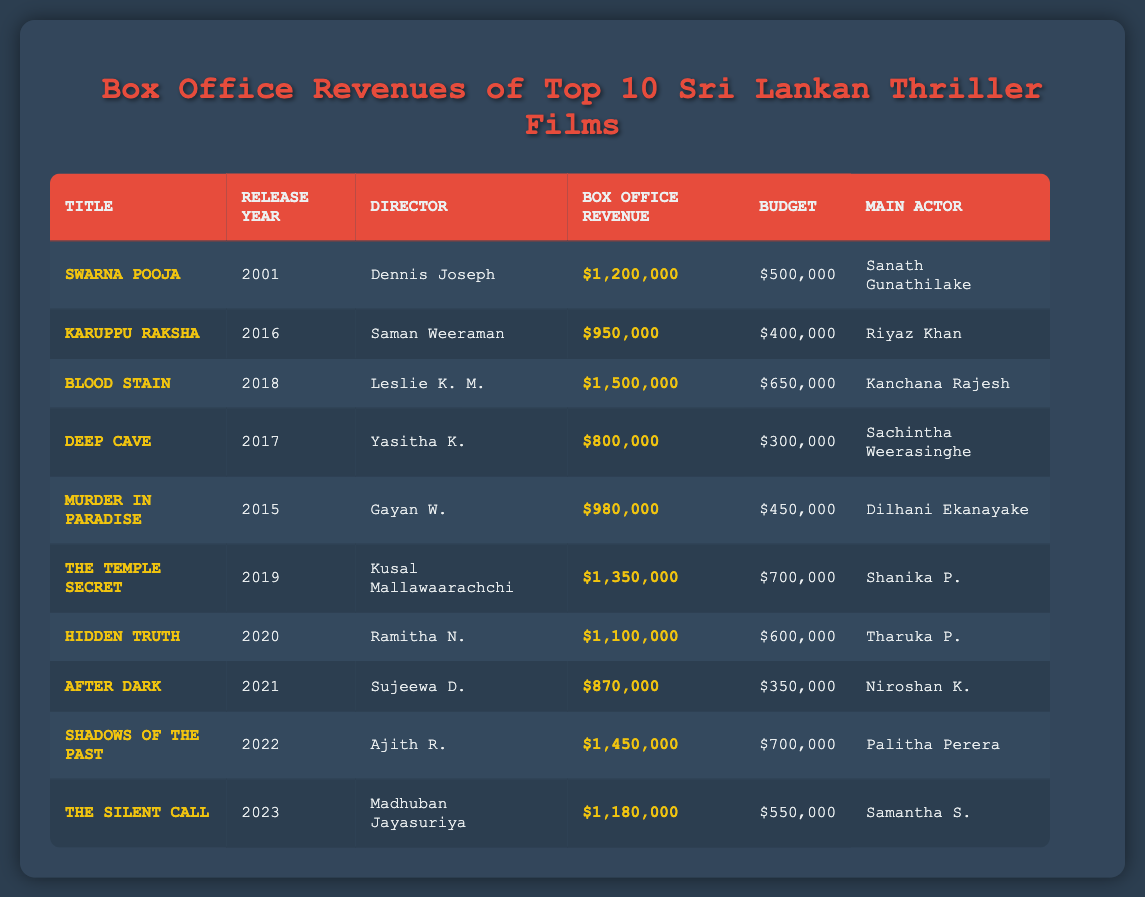What is the highest box office revenue among the listed films? The highest box office revenue shown in the table is $1,500,000 for "BLOOD STAIN".
Answer: $1,500,000 Who directed "THE TEMPLE SECRET"? The director of "THE TEMPLE SECRET" is Kusal Mallawaarachchi, as stated in the corresponding row of the table.
Answer: Kusal Mallawaarachchi Which film released in 2015 made a profit? "MURDER IN PARADISE" released in 2015 has a box office revenue of $980,000 and a budget of $450,000, resulting in a profit. Since revenue exceeds budget, it made a profit.
Answer: Yes What is the average box office revenue of the top 10 films? To find the average, add all box office revenues: $1,200,000 + $950,000 + $1,500,000 + $800,000 + $980,000 + $1,350,000 + $1,100,000 + $870,000 + $1,450,000 + $1,180,000 = $11,380,000. Then, divide by 10, so $11,380,000 / 10 = $1,138,000.
Answer: $1,138,000 Which film has the largest budget-to-revenue ratio and what is that ratio? Calculate the ratio for each film as Budget / Box Office Revenue. "DEEP CAVE" has a budget of $300,000 and revenue of $800,000, giving a ratio of $300,000 / $800,000 = 0.375. This is the smallest ratio, indicating it is the most cost-effective.
Answer: 0.375 Are there any films where the budget is above $600,000? By examining the budget values, "BLOOD STAIN," "THE TEMPLE SECRET," "HIDDEN TRUTH," and "SHADOWS OF THE PAST" all have budgets greater than $600,000. Therefore, the answer is yes.
Answer: Yes What is the total box office revenue for films released after 2018? The films released after 2018 are "HIDDEN TRUTH" ($1,100,000), "AFTER DARK" ($870,000), "SHADOWS OF THE PAST" ($1,450,000), and "THE SILENT CALL" ($1,180,000). Adding these yields $1,100,000 + $870,000 + $1,450,000 + $1,180,000 = $4,600,000.
Answer: $4,600,000 Which film features Sanath Gunathilake as the main actor? The film featuring Sanath Gunathilake is "SWARNA POOJA," as noted in the table under the "Main Actor" column.
Answer: SWARNA POOJA Is "AFTER DARK" more successful in box office revenue than "KARUPPU RAKSHA"? "AFTER DARK" has a revenue of $870,000, while "KARUPPU RAKSHA" has a revenue of $950,000, indicating that "KARUPPU RAKSHA" was more successful as it made more at the box office.
Answer: No What is the difference in revenue between "SHADOWS OF THE PAST" and "THE SILENT CALL"? "SHADOWS OF THE PAST" has a revenue of $1,450,000 and "THE SILENT CALL" $1,180,000. The difference is $1,450,000 - $1,180,000 = $270,000.
Answer: $270,000 